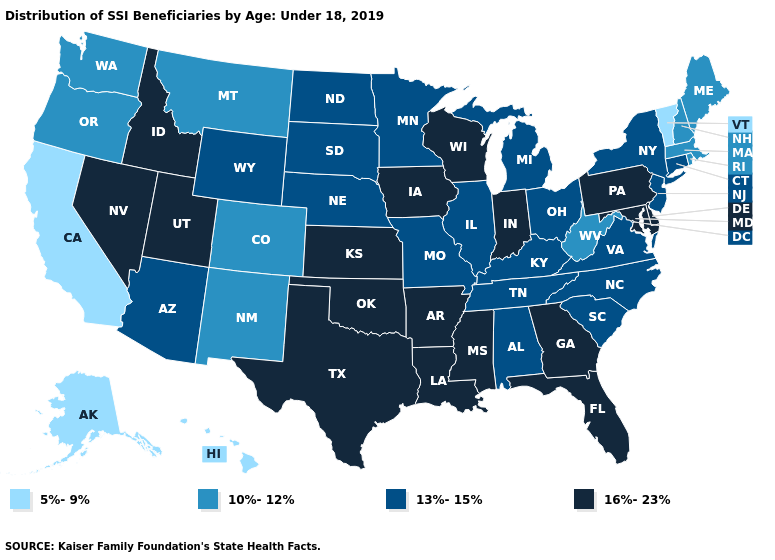Which states have the lowest value in the USA?
Quick response, please. Alaska, California, Hawaii, Vermont. What is the value of New Hampshire?
Concise answer only. 10%-12%. What is the value of Illinois?
Quick response, please. 13%-15%. Does Louisiana have a lower value than Alabama?
Short answer required. No. Name the states that have a value in the range 10%-12%?
Quick response, please. Colorado, Maine, Massachusetts, Montana, New Hampshire, New Mexico, Oregon, Rhode Island, Washington, West Virginia. Does California have the lowest value in the West?
Give a very brief answer. Yes. What is the highest value in states that border Iowa?
Quick response, please. 16%-23%. Does Missouri have the highest value in the MidWest?
Quick response, please. No. How many symbols are there in the legend?
Keep it brief. 4. Name the states that have a value in the range 5%-9%?
Keep it brief. Alaska, California, Hawaii, Vermont. Which states have the highest value in the USA?
Quick response, please. Arkansas, Delaware, Florida, Georgia, Idaho, Indiana, Iowa, Kansas, Louisiana, Maryland, Mississippi, Nevada, Oklahoma, Pennsylvania, Texas, Utah, Wisconsin. What is the value of North Carolina?
Answer briefly. 13%-15%. Does Wisconsin have the lowest value in the MidWest?
Concise answer only. No. Does the first symbol in the legend represent the smallest category?
Be succinct. Yes. How many symbols are there in the legend?
Concise answer only. 4. 